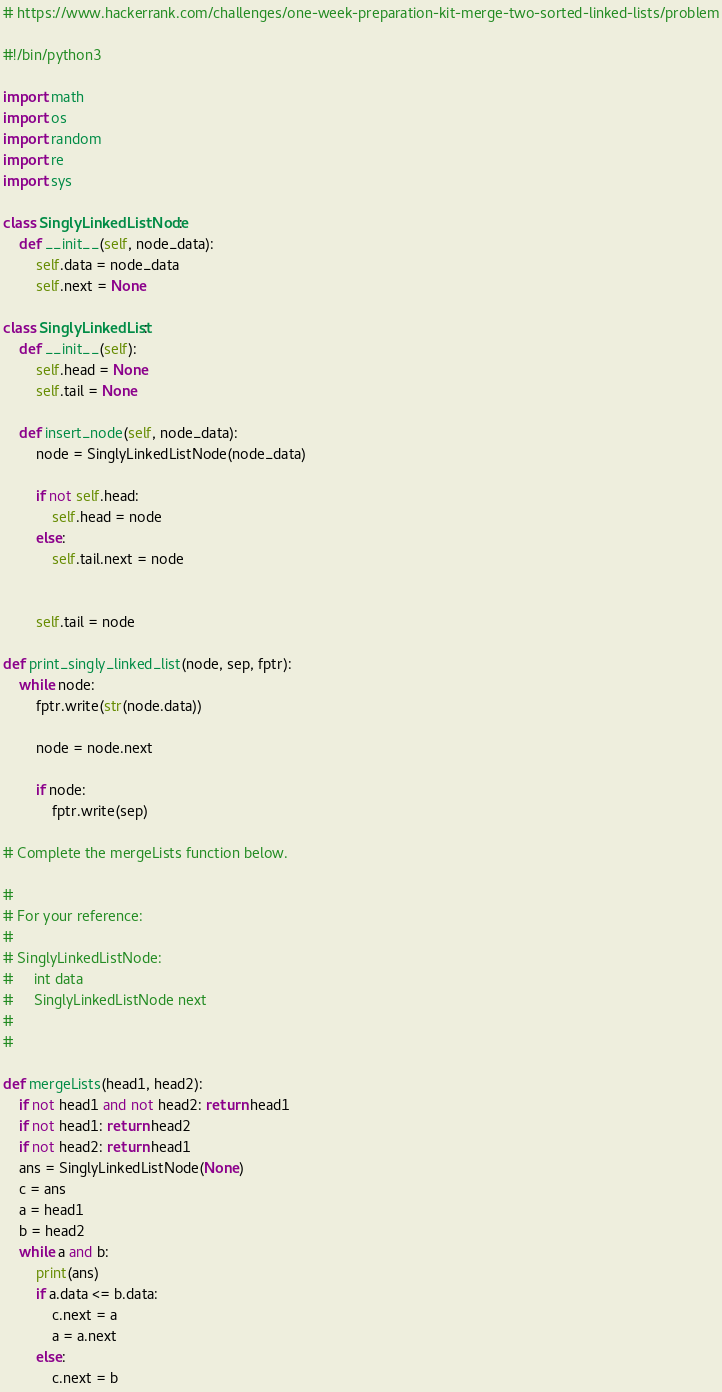<code> <loc_0><loc_0><loc_500><loc_500><_Python_># https://www.hackerrank.com/challenges/one-week-preparation-kit-merge-two-sorted-linked-lists/problem

#!/bin/python3

import math
import os
import random
import re
import sys

class SinglyLinkedListNode:
    def __init__(self, node_data):
        self.data = node_data
        self.next = None

class SinglyLinkedList:
    def __init__(self):
        self.head = None
        self.tail = None

    def insert_node(self, node_data):
        node = SinglyLinkedListNode(node_data)

        if not self.head:
            self.head = node
        else:
            self.tail.next = node


        self.tail = node

def print_singly_linked_list(node, sep, fptr):
    while node:
        fptr.write(str(node.data))

        node = node.next

        if node:
            fptr.write(sep)

# Complete the mergeLists function below.

#
# For your reference:
#
# SinglyLinkedListNode:
#     int data
#     SinglyLinkedListNode next
#
#

def mergeLists(head1, head2):
    if not head1 and not head2: return head1
    if not head1: return head2
    if not head2: return head1
    ans = SinglyLinkedListNode(None)
    c = ans
    a = head1
    b = head2
    while a and b:
        print(ans)
        if a.data <= b.data:
            c.next = a
            a = a.next
        else:
            c.next = b</code> 